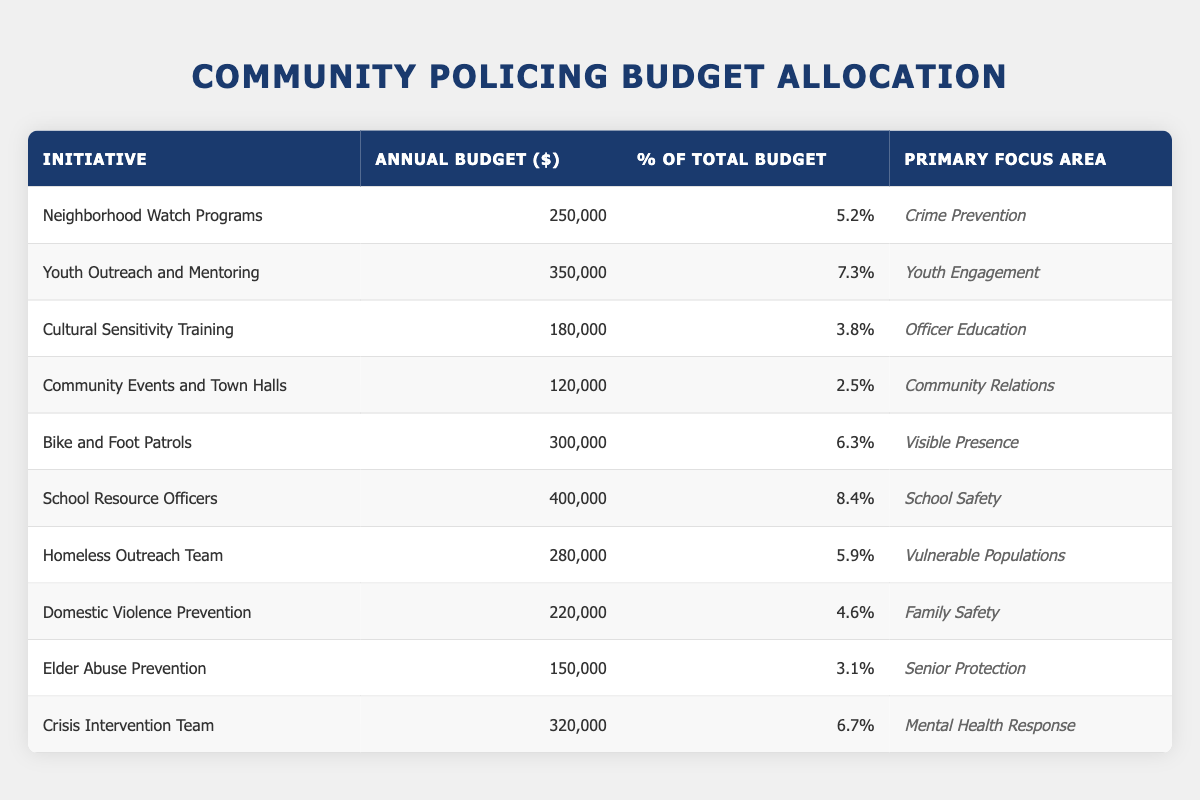What's the total budget allocated for the School Resource Officers initiative? Referring to the table, the budget for School Resource Officers is listed as 400,000.
Answer: 400,000 Which community policing initiative has the highest annual budget? The School Resource Officers initiative has the highest budget at 400,000 compared to the others.
Answer: School Resource Officers How much of the total budget is allocated to Crime Prevention initiatives? There are two initiatives related to Crime Prevention: Neighborhood Watch Programs and Domestic Violence Prevention, with budgets of 250,000 and 220,000 respectively. Summing these gives 250,000 + 220,000 = 470,000.
Answer: 470,000 Is the percentage of the total budget allocated to Domestic Violence Prevention higher than that for Elder Abuse Prevention? The table shows that Domestic Violence Prevention has 4.6% of the total budget while Elder Abuse Prevention has 3.1%. Since 4.6% is greater than 3.1%, the answer is yes.
Answer: Yes What is the average budget allocation for all initiatives focused on vulnerable populations? The initiatives listed under this focus area are the Homeless Outreach Team, with an annual budget of 280,000. Since there is only one entry in this category, the average is simply the budget itself, 280,000 / 1 = 280,000.
Answer: 280,000 What percentage of the total budget is allocated to community relations initiatives versus youth engagement initiatives? Community Events and Town Halls is the only initiative listed under community relations with a budget of 120,000 (2.5% of total), while Youth Outreach and Mentoring has a budget of 350,000 (7.3% of total). Comparing the percentages, 2.5% vs 7.3%, shows that youth engagement initiatives receive a higher percentage.
Answer: Youth engagement initiatives receive a higher percentage How much budget is allocated for visible presence initiatives compared to mental health response initiatives? The budget for Bike and Foot Patrols (visible presence) is 300,000, while for Crisis Intervention Team (mental health response) it is 320,000. The mental health response initiative has a higher allocation.
Answer: Mental health response initiative has a higher allocation What is the total budget for initiatives that fall under the category of officer education? Only the Cultural Sensitivity Training initiative falls under officer education, with a budget of 180,000, so the total for this category is simply 180,000.
Answer: 180,000 